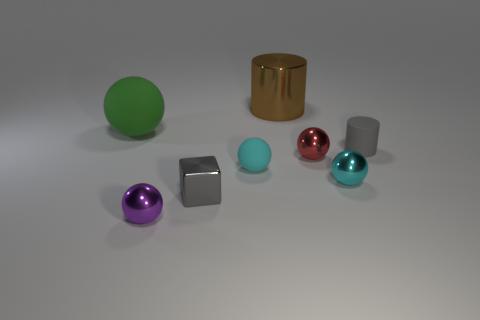The big brown thing has what shape?
Give a very brief answer. Cylinder. There is a small cube in front of the metal cylinder; what is its color?
Offer a terse response. Gray. Do the cyan ball to the left of the metal cylinder and the shiny cube have the same size?
Offer a very short reply. Yes. What is the size of the other cyan thing that is the same shape as the cyan matte thing?
Provide a succinct answer. Small. Do the big brown metallic thing and the small cyan shiny object have the same shape?
Provide a succinct answer. No. Are there fewer green rubber objects left of the red object than small metal balls that are on the right side of the purple thing?
Give a very brief answer. Yes. What number of red metallic spheres are behind the tiny gray cylinder?
Provide a short and direct response. 0. Does the tiny object on the left side of the gray metallic thing have the same shape as the large thing that is left of the large metal object?
Offer a very short reply. Yes. What number of other objects are the same color as the large metal thing?
Offer a terse response. 0. What is the material of the tiny gray thing behind the tiny gray thing on the left side of the thing that is behind the big green matte ball?
Provide a short and direct response. Rubber. 